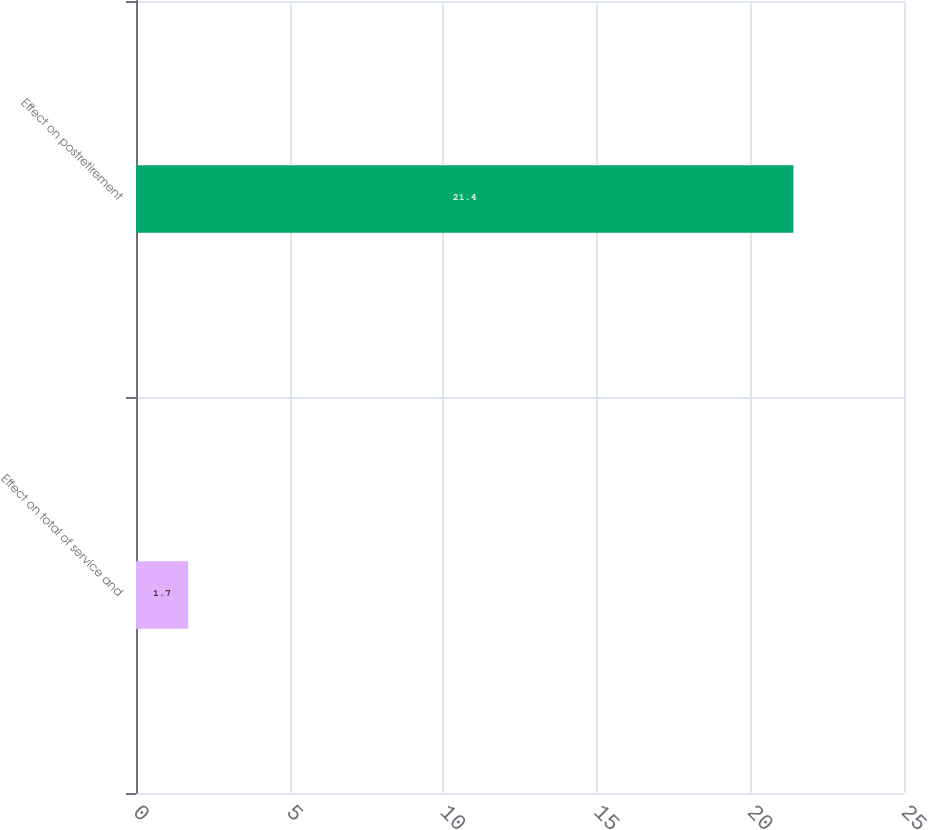<chart> <loc_0><loc_0><loc_500><loc_500><bar_chart><fcel>Effect on total of service and<fcel>Effect on postretirement<nl><fcel>1.7<fcel>21.4<nl></chart> 